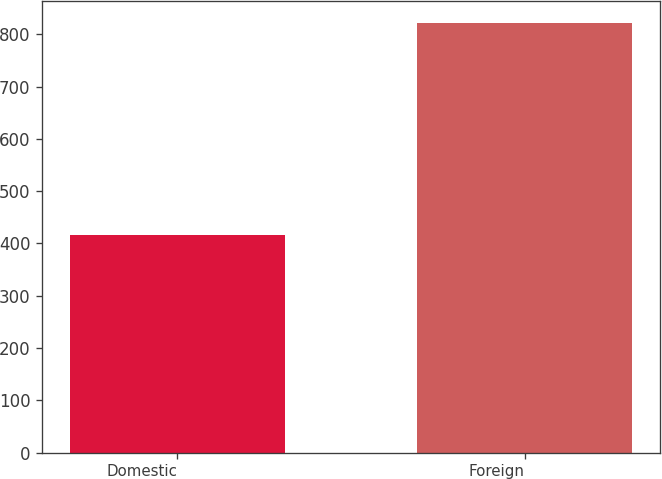Convert chart. <chart><loc_0><loc_0><loc_500><loc_500><bar_chart><fcel>Domestic<fcel>Foreign<nl><fcel>416.3<fcel>822.4<nl></chart> 